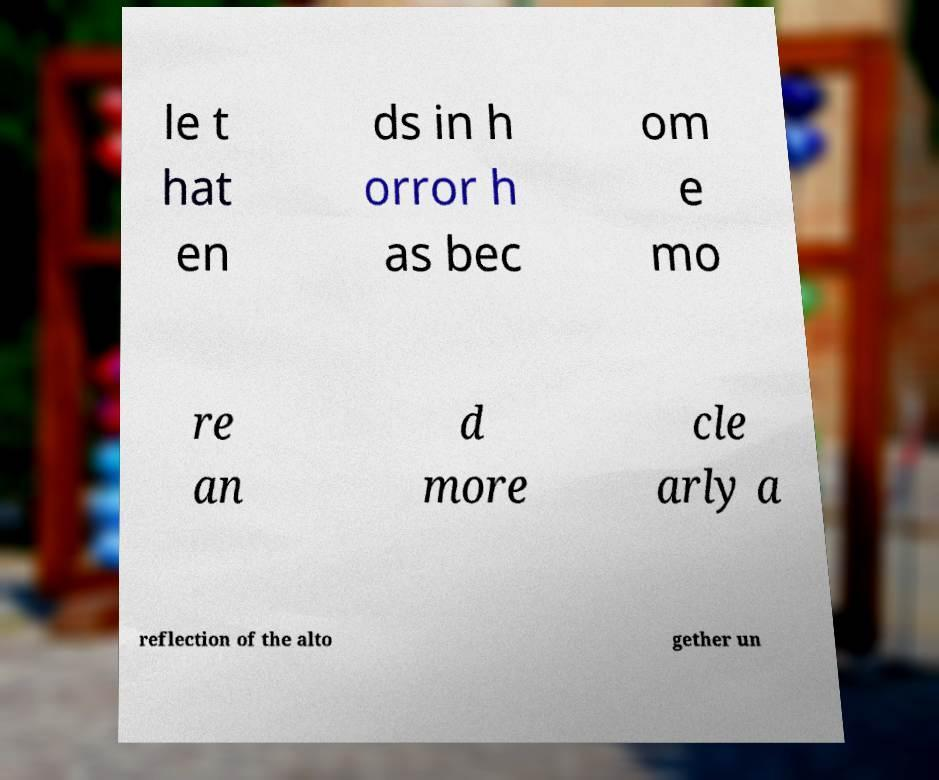I need the written content from this picture converted into text. Can you do that? le t hat en ds in h orror h as bec om e mo re an d more cle arly a reflection of the alto gether un 